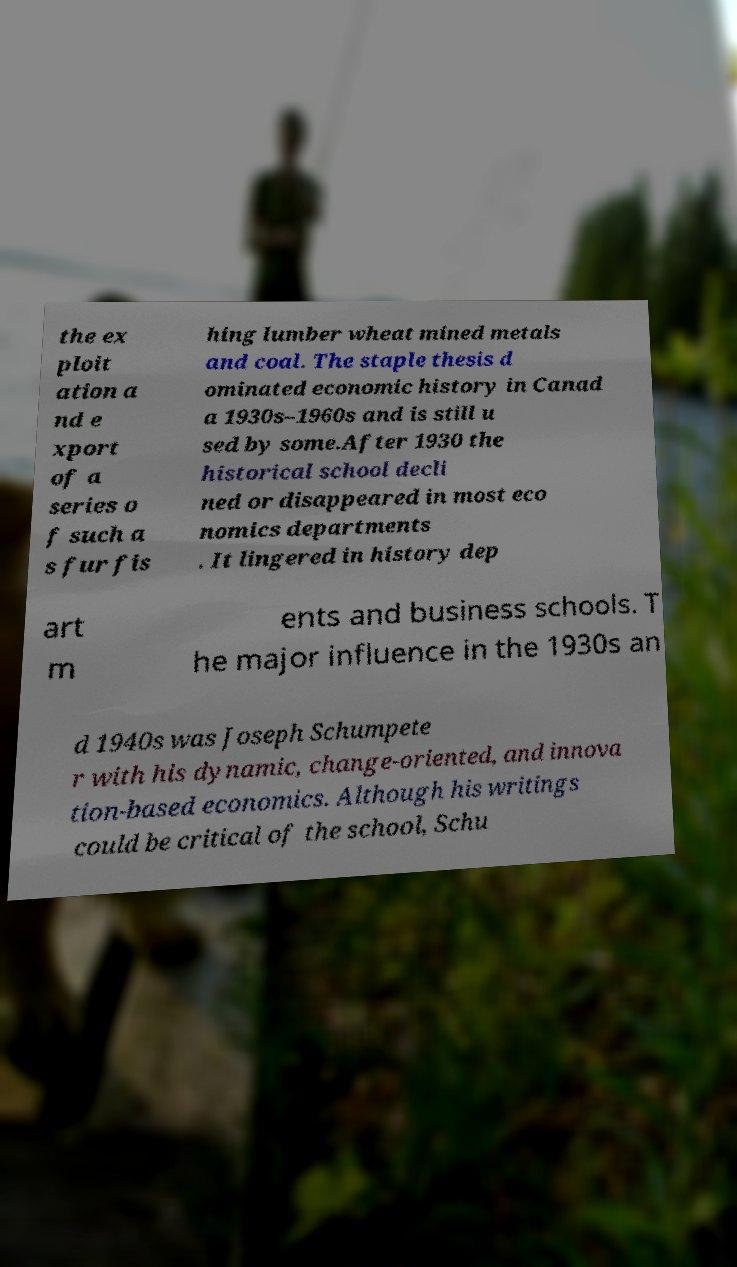Please read and relay the text visible in this image. What does it say? the ex ploit ation a nd e xport of a series o f such a s fur fis hing lumber wheat mined metals and coal. The staple thesis d ominated economic history in Canad a 1930s–1960s and is still u sed by some.After 1930 the historical school decli ned or disappeared in most eco nomics departments . It lingered in history dep art m ents and business schools. T he major influence in the 1930s an d 1940s was Joseph Schumpete r with his dynamic, change-oriented, and innova tion-based economics. Although his writings could be critical of the school, Schu 